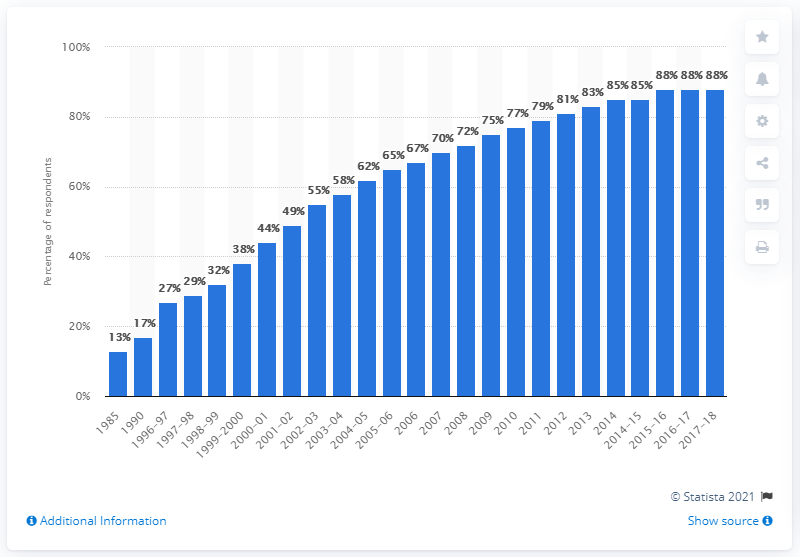Draw attention to some important aspects in this diagram. In 2015/16, approximately 88% of households in the UK owned a home computer. 